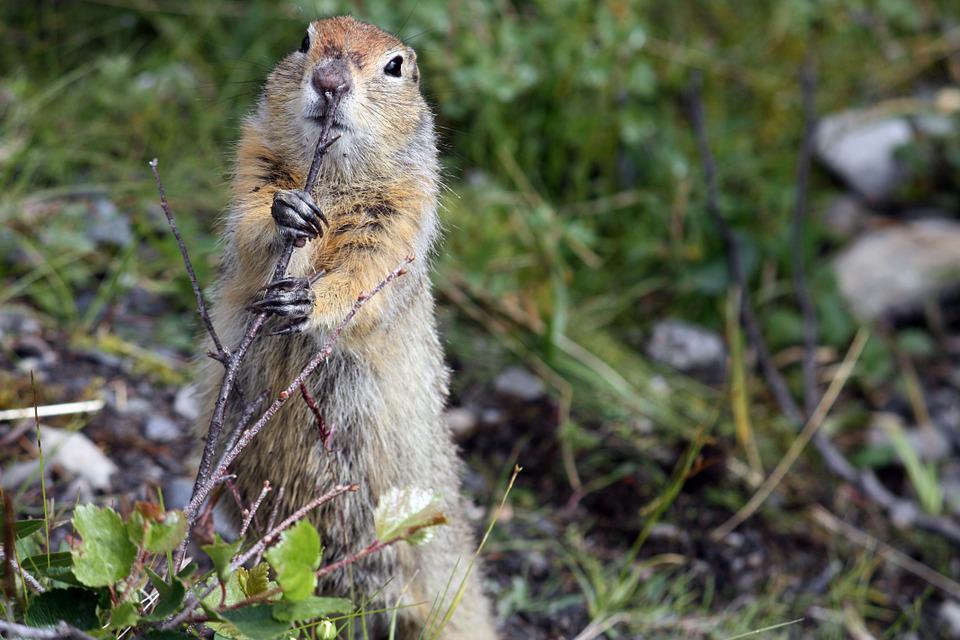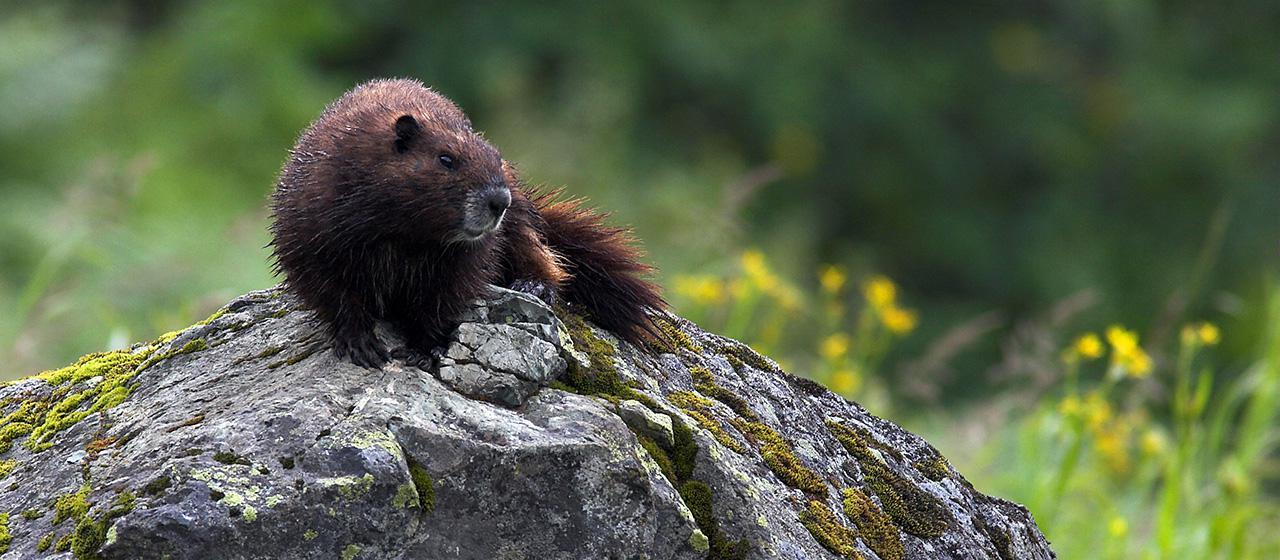The first image is the image on the left, the second image is the image on the right. Analyze the images presented: Is the assertion "One image depicts an adult animal and at least one younger rodent." valid? Answer yes or no. No. 